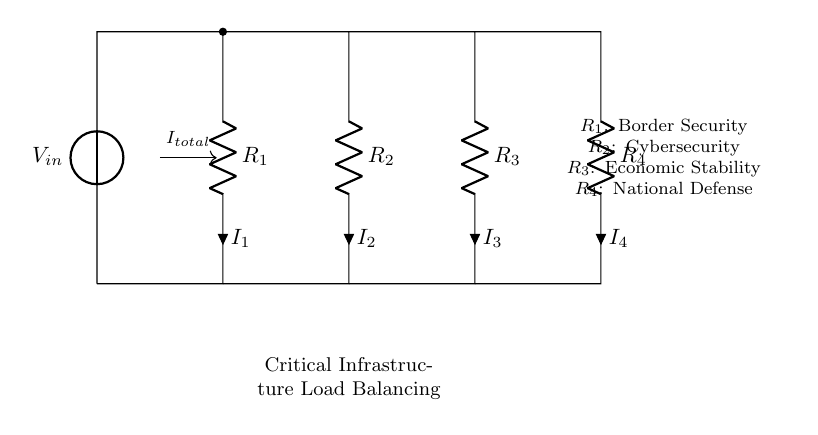What does R1 represent in this circuit? R1 represents border security, which suggests a component of critical infrastructure.
Answer: Border Security What is the current labeled as I_total? I_total is the total current entering the parallel resistor network before it is divided into I1, I2, I3, and I4.
Answer: Total Current How many resistors are in this circuit? There are four resistors in the circuit diagram, each representing different aspects of critical infrastructure.
Answer: Four Which resistor represents cybersecurity? R2 represents cybersecurity based on the labeling in the circuit diagram.
Answer: R2 What is the function of the parallel configuration in this circuit? The parallel configuration allows for load balancing, ensuring that each component can operate independently while sharing the current.
Answer: Load Balancing If the total current is 10 amperes, how would it divide among the resistors? The current divides inversely proportional to the resistance values. Without specific resistance values, the exact distribution cannot be calculated but observed qualitatively in the circuit setup.
Answer: Depends on resistance values What is the significance of the node labeled as Critical Infrastructure Load Balancing? This node indicates the importance of balancing the load among multiple components to maintain stability in critical infrastructure systems.
Answer: Stability in Critical Infrastructure 